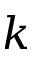<formula> <loc_0><loc_0><loc_500><loc_500>k</formula> 